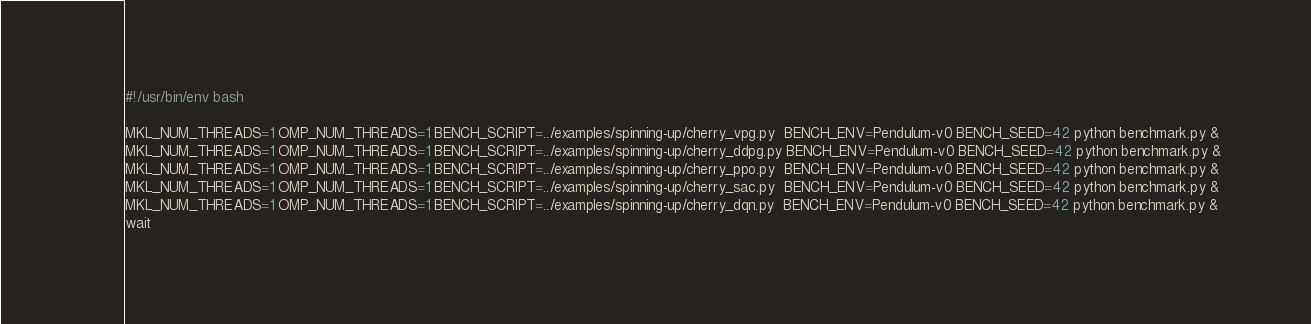Convert code to text. <code><loc_0><loc_0><loc_500><loc_500><_Bash_>#!/usr/bin/env bash

MKL_NUM_THREADS=1 OMP_NUM_THREADS=1 BENCH_SCRIPT=../examples/spinning-up/cherry_vpg.py  BENCH_ENV=Pendulum-v0 BENCH_SEED=42 python benchmark.py &
MKL_NUM_THREADS=1 OMP_NUM_THREADS=1 BENCH_SCRIPT=../examples/spinning-up/cherry_ddpg.py BENCH_ENV=Pendulum-v0 BENCH_SEED=42 python benchmark.py &
MKL_NUM_THREADS=1 OMP_NUM_THREADS=1 BENCH_SCRIPT=../examples/spinning-up/cherry_ppo.py  BENCH_ENV=Pendulum-v0 BENCH_SEED=42 python benchmark.py &
MKL_NUM_THREADS=1 OMP_NUM_THREADS=1 BENCH_SCRIPT=../examples/spinning-up/cherry_sac.py  BENCH_ENV=Pendulum-v0 BENCH_SEED=42 python benchmark.py &
MKL_NUM_THREADS=1 OMP_NUM_THREADS=1 BENCH_SCRIPT=../examples/spinning-up/cherry_dqn.py  BENCH_ENV=Pendulum-v0 BENCH_SEED=42 python benchmark.py &
wait
</code> 